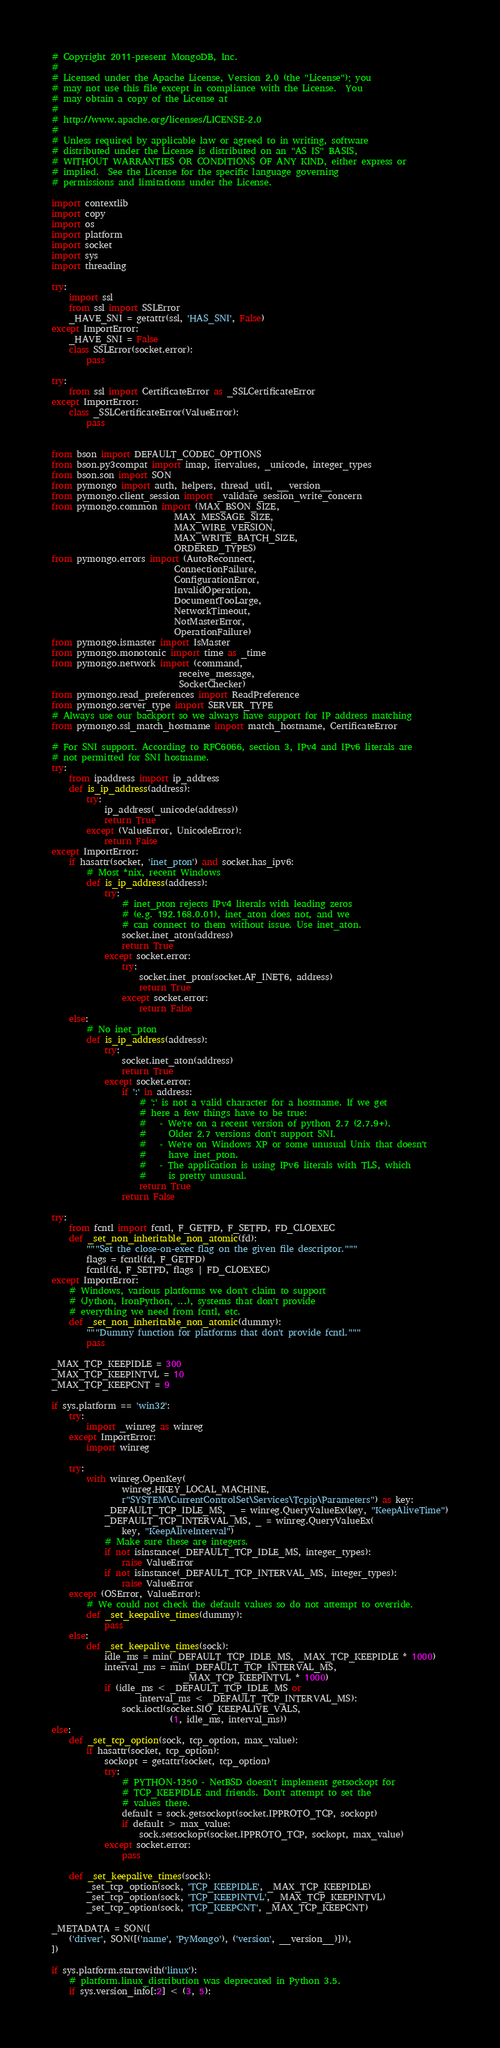Convert code to text. <code><loc_0><loc_0><loc_500><loc_500><_Python_># Copyright 2011-present MongoDB, Inc.
#
# Licensed under the Apache License, Version 2.0 (the "License"); you
# may not use this file except in compliance with the License.  You
# may obtain a copy of the License at
#
# http://www.apache.org/licenses/LICENSE-2.0
#
# Unless required by applicable law or agreed to in writing, software
# distributed under the License is distributed on an "AS IS" BASIS,
# WITHOUT WARRANTIES OR CONDITIONS OF ANY KIND, either express or
# implied.  See the License for the specific language governing
# permissions and limitations under the License.

import contextlib
import copy
import os
import platform
import socket
import sys
import threading

try:
    import ssl
    from ssl import SSLError
    _HAVE_SNI = getattr(ssl, 'HAS_SNI', False)
except ImportError:
    _HAVE_SNI = False
    class SSLError(socket.error):
        pass

try:
    from ssl import CertificateError as _SSLCertificateError
except ImportError:
    class _SSLCertificateError(ValueError):
        pass


from bson import DEFAULT_CODEC_OPTIONS
from bson.py3compat import imap, itervalues, _unicode, integer_types
from bson.son import SON
from pymongo import auth, helpers, thread_util, __version__
from pymongo.client_session import _validate_session_write_concern
from pymongo.common import (MAX_BSON_SIZE,
                            MAX_MESSAGE_SIZE,
                            MAX_WIRE_VERSION,
                            MAX_WRITE_BATCH_SIZE,
                            ORDERED_TYPES)
from pymongo.errors import (AutoReconnect,
                            ConnectionFailure,
                            ConfigurationError,
                            InvalidOperation,
                            DocumentTooLarge,
                            NetworkTimeout,
                            NotMasterError,
                            OperationFailure)
from pymongo.ismaster import IsMaster
from pymongo.monotonic import time as _time
from pymongo.network import (command,
                             receive_message,
                             SocketChecker)
from pymongo.read_preferences import ReadPreference
from pymongo.server_type import SERVER_TYPE
# Always use our backport so we always have support for IP address matching
from pymongo.ssl_match_hostname import match_hostname, CertificateError

# For SNI support. According to RFC6066, section 3, IPv4 and IPv6 literals are
# not permitted for SNI hostname.
try:
    from ipaddress import ip_address
    def is_ip_address(address):
        try:
            ip_address(_unicode(address))
            return True
        except (ValueError, UnicodeError):
            return False
except ImportError:
    if hasattr(socket, 'inet_pton') and socket.has_ipv6:
        # Most *nix, recent Windows
        def is_ip_address(address):
            try:
                # inet_pton rejects IPv4 literals with leading zeros
                # (e.g. 192.168.0.01), inet_aton does not, and we
                # can connect to them without issue. Use inet_aton.
                socket.inet_aton(address)
                return True
            except socket.error:
                try:
                    socket.inet_pton(socket.AF_INET6, address)
                    return True
                except socket.error:
                    return False
    else:
        # No inet_pton
        def is_ip_address(address):
            try:
                socket.inet_aton(address)
                return True
            except socket.error:
                if ':' in address:
                    # ':' is not a valid character for a hostname. If we get
                    # here a few things have to be true:
                    #   - We're on a recent version of python 2.7 (2.7.9+).
                    #     Older 2.7 versions don't support SNI.
                    #   - We're on Windows XP or some unusual Unix that doesn't
                    #     have inet_pton.
                    #   - The application is using IPv6 literals with TLS, which
                    #     is pretty unusual.
                    return True
                return False

try:
    from fcntl import fcntl, F_GETFD, F_SETFD, FD_CLOEXEC
    def _set_non_inheritable_non_atomic(fd):
        """Set the close-on-exec flag on the given file descriptor."""
        flags = fcntl(fd, F_GETFD)
        fcntl(fd, F_SETFD, flags | FD_CLOEXEC)
except ImportError:
    # Windows, various platforms we don't claim to support
    # (Jython, IronPython, ...), systems that don't provide
    # everything we need from fcntl, etc.
    def _set_non_inheritable_non_atomic(dummy):
        """Dummy function for platforms that don't provide fcntl."""
        pass

_MAX_TCP_KEEPIDLE = 300
_MAX_TCP_KEEPINTVL = 10
_MAX_TCP_KEEPCNT = 9

if sys.platform == 'win32':
    try:
        import _winreg as winreg
    except ImportError:
        import winreg

    try:
        with winreg.OpenKey(
                winreg.HKEY_LOCAL_MACHINE,
                r"SYSTEM\CurrentControlSet\Services\Tcpip\Parameters") as key:
            _DEFAULT_TCP_IDLE_MS, _ = winreg.QueryValueEx(key, "KeepAliveTime")
            _DEFAULT_TCP_INTERVAL_MS, _ = winreg.QueryValueEx(
                key, "KeepAliveInterval")
            # Make sure these are integers.
            if not isinstance(_DEFAULT_TCP_IDLE_MS, integer_types):
                raise ValueError
            if not isinstance(_DEFAULT_TCP_INTERVAL_MS, integer_types):
                raise ValueError
    except (OSError, ValueError):
        # We could not check the default values so do not attempt to override.
        def _set_keepalive_times(dummy):
            pass
    else:
        def _set_keepalive_times(sock):
            idle_ms = min(_DEFAULT_TCP_IDLE_MS, _MAX_TCP_KEEPIDLE * 1000)
            interval_ms = min(_DEFAULT_TCP_INTERVAL_MS,
                              _MAX_TCP_KEEPINTVL * 1000)
            if (idle_ms < _DEFAULT_TCP_IDLE_MS or
                    interval_ms < _DEFAULT_TCP_INTERVAL_MS):
                sock.ioctl(socket.SIO_KEEPALIVE_VALS,
                           (1, idle_ms, interval_ms))
else:
    def _set_tcp_option(sock, tcp_option, max_value):
        if hasattr(socket, tcp_option):
            sockopt = getattr(socket, tcp_option)
            try:
                # PYTHON-1350 - NetBSD doesn't implement getsockopt for
                # TCP_KEEPIDLE and friends. Don't attempt to set the
                # values there.
                default = sock.getsockopt(socket.IPPROTO_TCP, sockopt)
                if default > max_value:
                    sock.setsockopt(socket.IPPROTO_TCP, sockopt, max_value)
            except socket.error:
                pass

    def _set_keepalive_times(sock):
        _set_tcp_option(sock, 'TCP_KEEPIDLE', _MAX_TCP_KEEPIDLE)
        _set_tcp_option(sock, 'TCP_KEEPINTVL', _MAX_TCP_KEEPINTVL)
        _set_tcp_option(sock, 'TCP_KEEPCNT', _MAX_TCP_KEEPCNT)

_METADATA = SON([
    ('driver', SON([('name', 'PyMongo'), ('version', __version__)])),
])

if sys.platform.startswith('linux'):
    # platform.linux_distribution was deprecated in Python 3.5.
    if sys.version_info[:2] < (3, 5):</code> 